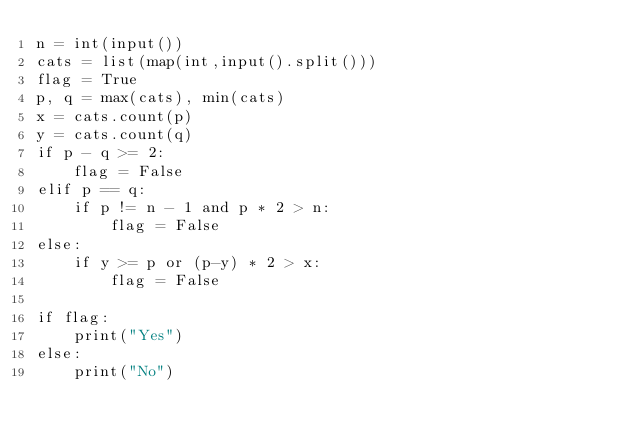Convert code to text. <code><loc_0><loc_0><loc_500><loc_500><_Python_>n = int(input())
cats = list(map(int,input().split()))
flag = True
p, q = max(cats), min(cats)
x = cats.count(p)
y = cats.count(q)
if p - q >= 2:
    flag = False
elif p == q:
    if p != n - 1 and p * 2 > n:
        flag = False
else:
    if y >= p or (p-y) * 2 > x:
        flag = False

if flag:
    print("Yes")
else:
    print("No")</code> 